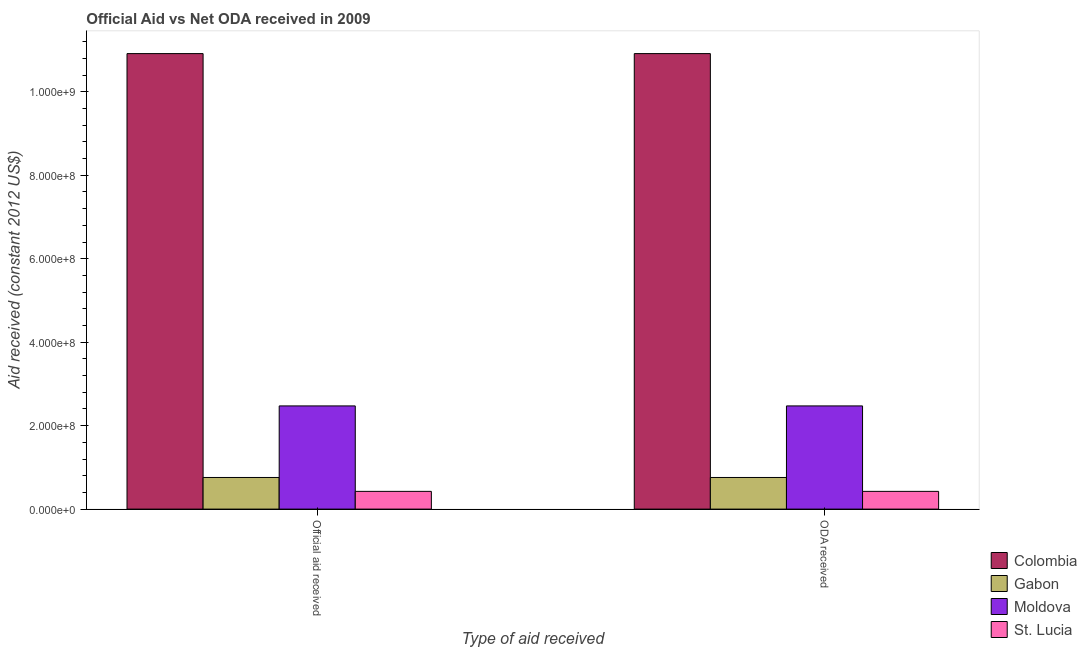Are the number of bars per tick equal to the number of legend labels?
Keep it short and to the point. Yes. How many bars are there on the 1st tick from the left?
Your answer should be compact. 4. How many bars are there on the 2nd tick from the right?
Your answer should be compact. 4. What is the label of the 1st group of bars from the left?
Your answer should be compact. Official aid received. What is the oda received in Moldova?
Your answer should be very brief. 2.47e+08. Across all countries, what is the maximum official aid received?
Your answer should be very brief. 1.09e+09. Across all countries, what is the minimum official aid received?
Your answer should be very brief. 4.25e+07. In which country was the official aid received minimum?
Provide a short and direct response. St. Lucia. What is the total oda received in the graph?
Your response must be concise. 1.46e+09. What is the difference between the official aid received in St. Lucia and that in Colombia?
Your answer should be very brief. -1.05e+09. What is the difference between the official aid received in Gabon and the oda received in Colombia?
Provide a short and direct response. -1.02e+09. What is the average oda received per country?
Your answer should be very brief. 3.64e+08. In how many countries, is the official aid received greater than 960000000 US$?
Keep it short and to the point. 1. What is the ratio of the oda received in Moldova to that in Colombia?
Offer a terse response. 0.23. Is the oda received in Gabon less than that in St. Lucia?
Your answer should be very brief. No. What does the 4th bar from the left in Official aid received represents?
Ensure brevity in your answer.  St. Lucia. What does the 1st bar from the right in Official aid received represents?
Offer a terse response. St. Lucia. How many bars are there?
Provide a short and direct response. 8. How many countries are there in the graph?
Make the answer very short. 4. Does the graph contain any zero values?
Keep it short and to the point. No. Does the graph contain grids?
Your response must be concise. No. How many legend labels are there?
Your answer should be very brief. 4. What is the title of the graph?
Your answer should be very brief. Official Aid vs Net ODA received in 2009 . What is the label or title of the X-axis?
Your answer should be very brief. Type of aid received. What is the label or title of the Y-axis?
Your answer should be compact. Aid received (constant 2012 US$). What is the Aid received (constant 2012 US$) of Colombia in Official aid received?
Offer a terse response. 1.09e+09. What is the Aid received (constant 2012 US$) of Gabon in Official aid received?
Make the answer very short. 7.58e+07. What is the Aid received (constant 2012 US$) of Moldova in Official aid received?
Offer a very short reply. 2.47e+08. What is the Aid received (constant 2012 US$) in St. Lucia in Official aid received?
Provide a succinct answer. 4.25e+07. What is the Aid received (constant 2012 US$) in Colombia in ODA received?
Your response must be concise. 1.09e+09. What is the Aid received (constant 2012 US$) in Gabon in ODA received?
Your answer should be compact. 7.58e+07. What is the Aid received (constant 2012 US$) of Moldova in ODA received?
Provide a succinct answer. 2.47e+08. What is the Aid received (constant 2012 US$) of St. Lucia in ODA received?
Your response must be concise. 4.25e+07. Across all Type of aid received, what is the maximum Aid received (constant 2012 US$) of Colombia?
Provide a succinct answer. 1.09e+09. Across all Type of aid received, what is the maximum Aid received (constant 2012 US$) in Gabon?
Ensure brevity in your answer.  7.58e+07. Across all Type of aid received, what is the maximum Aid received (constant 2012 US$) of Moldova?
Your response must be concise. 2.47e+08. Across all Type of aid received, what is the maximum Aid received (constant 2012 US$) of St. Lucia?
Give a very brief answer. 4.25e+07. Across all Type of aid received, what is the minimum Aid received (constant 2012 US$) in Colombia?
Your answer should be compact. 1.09e+09. Across all Type of aid received, what is the minimum Aid received (constant 2012 US$) in Gabon?
Provide a succinct answer. 7.58e+07. Across all Type of aid received, what is the minimum Aid received (constant 2012 US$) of Moldova?
Your response must be concise. 2.47e+08. Across all Type of aid received, what is the minimum Aid received (constant 2012 US$) of St. Lucia?
Provide a succinct answer. 4.25e+07. What is the total Aid received (constant 2012 US$) of Colombia in the graph?
Ensure brevity in your answer.  2.18e+09. What is the total Aid received (constant 2012 US$) of Gabon in the graph?
Offer a very short reply. 1.52e+08. What is the total Aid received (constant 2012 US$) in Moldova in the graph?
Make the answer very short. 4.95e+08. What is the total Aid received (constant 2012 US$) in St. Lucia in the graph?
Make the answer very short. 8.50e+07. What is the difference between the Aid received (constant 2012 US$) in St. Lucia in Official aid received and that in ODA received?
Offer a very short reply. 0. What is the difference between the Aid received (constant 2012 US$) of Colombia in Official aid received and the Aid received (constant 2012 US$) of Gabon in ODA received?
Your response must be concise. 1.02e+09. What is the difference between the Aid received (constant 2012 US$) of Colombia in Official aid received and the Aid received (constant 2012 US$) of Moldova in ODA received?
Make the answer very short. 8.44e+08. What is the difference between the Aid received (constant 2012 US$) in Colombia in Official aid received and the Aid received (constant 2012 US$) in St. Lucia in ODA received?
Your answer should be compact. 1.05e+09. What is the difference between the Aid received (constant 2012 US$) in Gabon in Official aid received and the Aid received (constant 2012 US$) in Moldova in ODA received?
Offer a terse response. -1.71e+08. What is the difference between the Aid received (constant 2012 US$) in Gabon in Official aid received and the Aid received (constant 2012 US$) in St. Lucia in ODA received?
Make the answer very short. 3.33e+07. What is the difference between the Aid received (constant 2012 US$) in Moldova in Official aid received and the Aid received (constant 2012 US$) in St. Lucia in ODA received?
Give a very brief answer. 2.05e+08. What is the average Aid received (constant 2012 US$) of Colombia per Type of aid received?
Make the answer very short. 1.09e+09. What is the average Aid received (constant 2012 US$) in Gabon per Type of aid received?
Your response must be concise. 7.58e+07. What is the average Aid received (constant 2012 US$) of Moldova per Type of aid received?
Your response must be concise. 2.47e+08. What is the average Aid received (constant 2012 US$) of St. Lucia per Type of aid received?
Your answer should be very brief. 4.25e+07. What is the difference between the Aid received (constant 2012 US$) in Colombia and Aid received (constant 2012 US$) in Gabon in Official aid received?
Provide a short and direct response. 1.02e+09. What is the difference between the Aid received (constant 2012 US$) of Colombia and Aid received (constant 2012 US$) of Moldova in Official aid received?
Give a very brief answer. 8.44e+08. What is the difference between the Aid received (constant 2012 US$) of Colombia and Aid received (constant 2012 US$) of St. Lucia in Official aid received?
Provide a short and direct response. 1.05e+09. What is the difference between the Aid received (constant 2012 US$) in Gabon and Aid received (constant 2012 US$) in Moldova in Official aid received?
Make the answer very short. -1.71e+08. What is the difference between the Aid received (constant 2012 US$) of Gabon and Aid received (constant 2012 US$) of St. Lucia in Official aid received?
Offer a very short reply. 3.33e+07. What is the difference between the Aid received (constant 2012 US$) of Moldova and Aid received (constant 2012 US$) of St. Lucia in Official aid received?
Offer a terse response. 2.05e+08. What is the difference between the Aid received (constant 2012 US$) of Colombia and Aid received (constant 2012 US$) of Gabon in ODA received?
Give a very brief answer. 1.02e+09. What is the difference between the Aid received (constant 2012 US$) of Colombia and Aid received (constant 2012 US$) of Moldova in ODA received?
Offer a terse response. 8.44e+08. What is the difference between the Aid received (constant 2012 US$) in Colombia and Aid received (constant 2012 US$) in St. Lucia in ODA received?
Your answer should be very brief. 1.05e+09. What is the difference between the Aid received (constant 2012 US$) of Gabon and Aid received (constant 2012 US$) of Moldova in ODA received?
Ensure brevity in your answer.  -1.71e+08. What is the difference between the Aid received (constant 2012 US$) of Gabon and Aid received (constant 2012 US$) of St. Lucia in ODA received?
Offer a very short reply. 3.33e+07. What is the difference between the Aid received (constant 2012 US$) in Moldova and Aid received (constant 2012 US$) in St. Lucia in ODA received?
Give a very brief answer. 2.05e+08. What is the ratio of the Aid received (constant 2012 US$) in Gabon in Official aid received to that in ODA received?
Your answer should be very brief. 1. What is the ratio of the Aid received (constant 2012 US$) of St. Lucia in Official aid received to that in ODA received?
Provide a short and direct response. 1. What is the difference between the highest and the second highest Aid received (constant 2012 US$) in Colombia?
Offer a very short reply. 0. What is the difference between the highest and the lowest Aid received (constant 2012 US$) of Moldova?
Offer a very short reply. 0. What is the difference between the highest and the lowest Aid received (constant 2012 US$) of St. Lucia?
Make the answer very short. 0. 